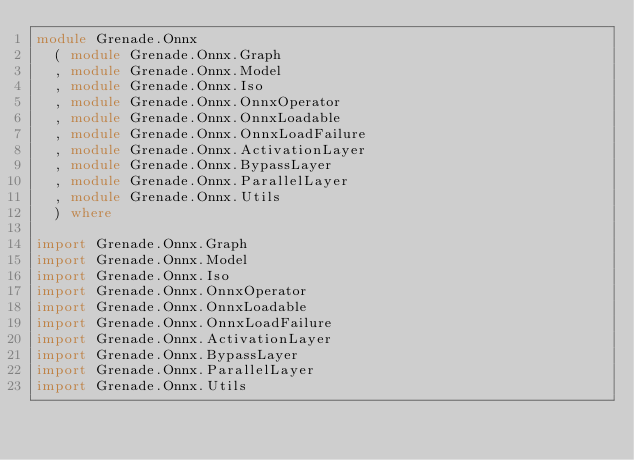Convert code to text. <code><loc_0><loc_0><loc_500><loc_500><_Haskell_>module Grenade.Onnx
  ( module Grenade.Onnx.Graph
  , module Grenade.Onnx.Model
  , module Grenade.Onnx.Iso
  , module Grenade.Onnx.OnnxOperator
  , module Grenade.Onnx.OnnxLoadable
  , module Grenade.Onnx.OnnxLoadFailure
  , module Grenade.Onnx.ActivationLayer
  , module Grenade.Onnx.BypassLayer
  , module Grenade.Onnx.ParallelLayer
  , module Grenade.Onnx.Utils
  ) where

import Grenade.Onnx.Graph
import Grenade.Onnx.Model
import Grenade.Onnx.Iso
import Grenade.Onnx.OnnxOperator
import Grenade.Onnx.OnnxLoadable
import Grenade.Onnx.OnnxLoadFailure
import Grenade.Onnx.ActivationLayer
import Grenade.Onnx.BypassLayer
import Grenade.Onnx.ParallelLayer
import Grenade.Onnx.Utils
</code> 